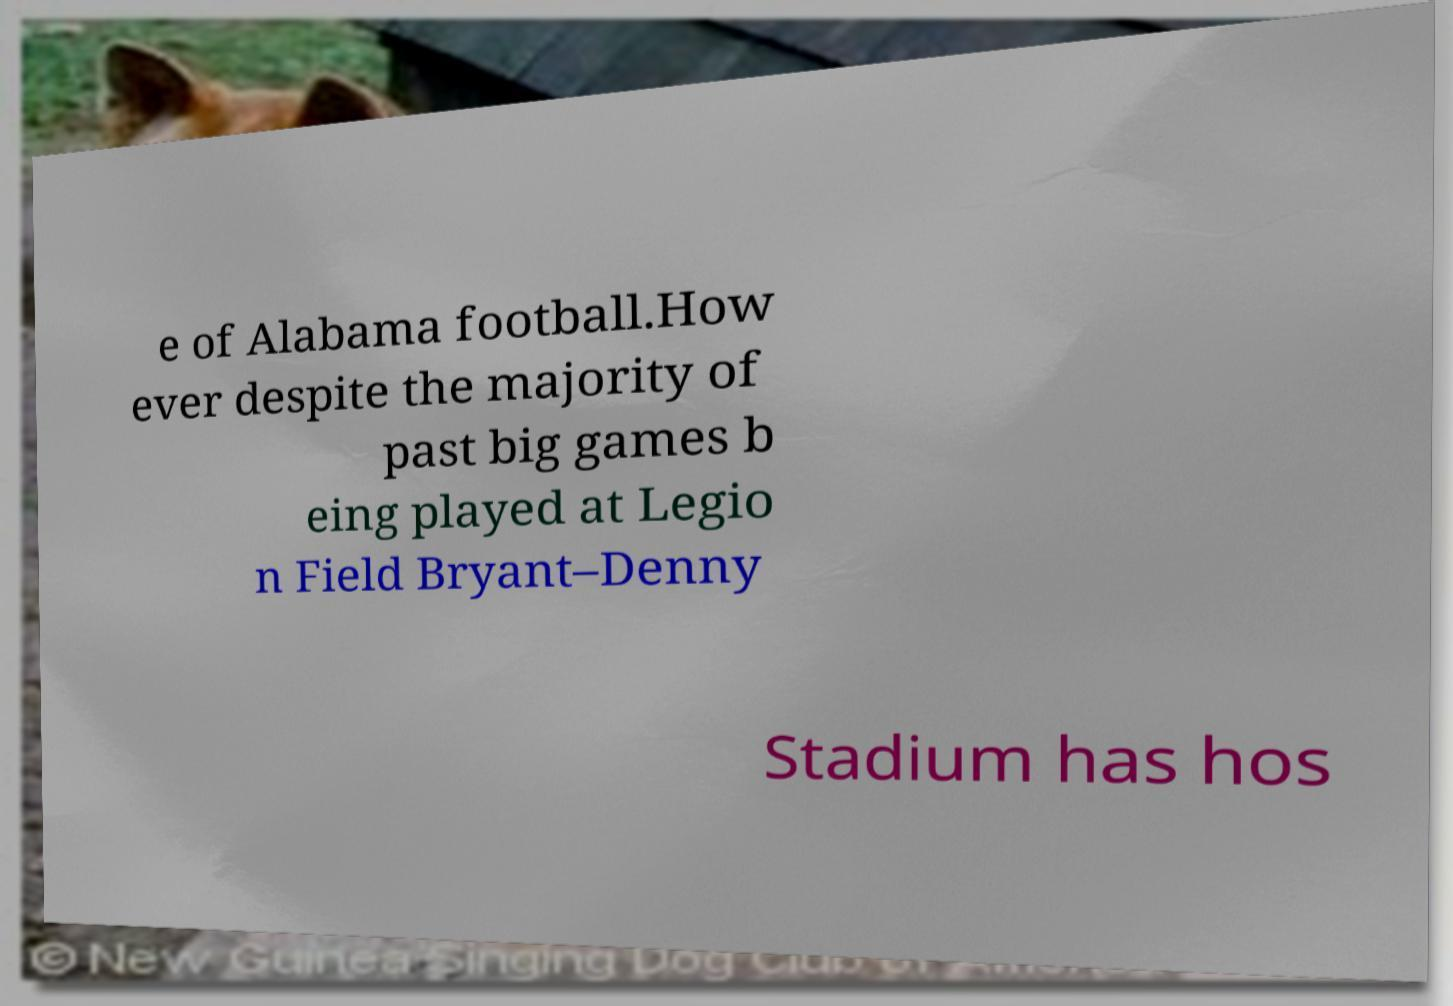I need the written content from this picture converted into text. Can you do that? e of Alabama football.How ever despite the majority of past big games b eing played at Legio n Field Bryant–Denny Stadium has hos 